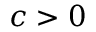Convert formula to latex. <formula><loc_0><loc_0><loc_500><loc_500>c > 0</formula> 